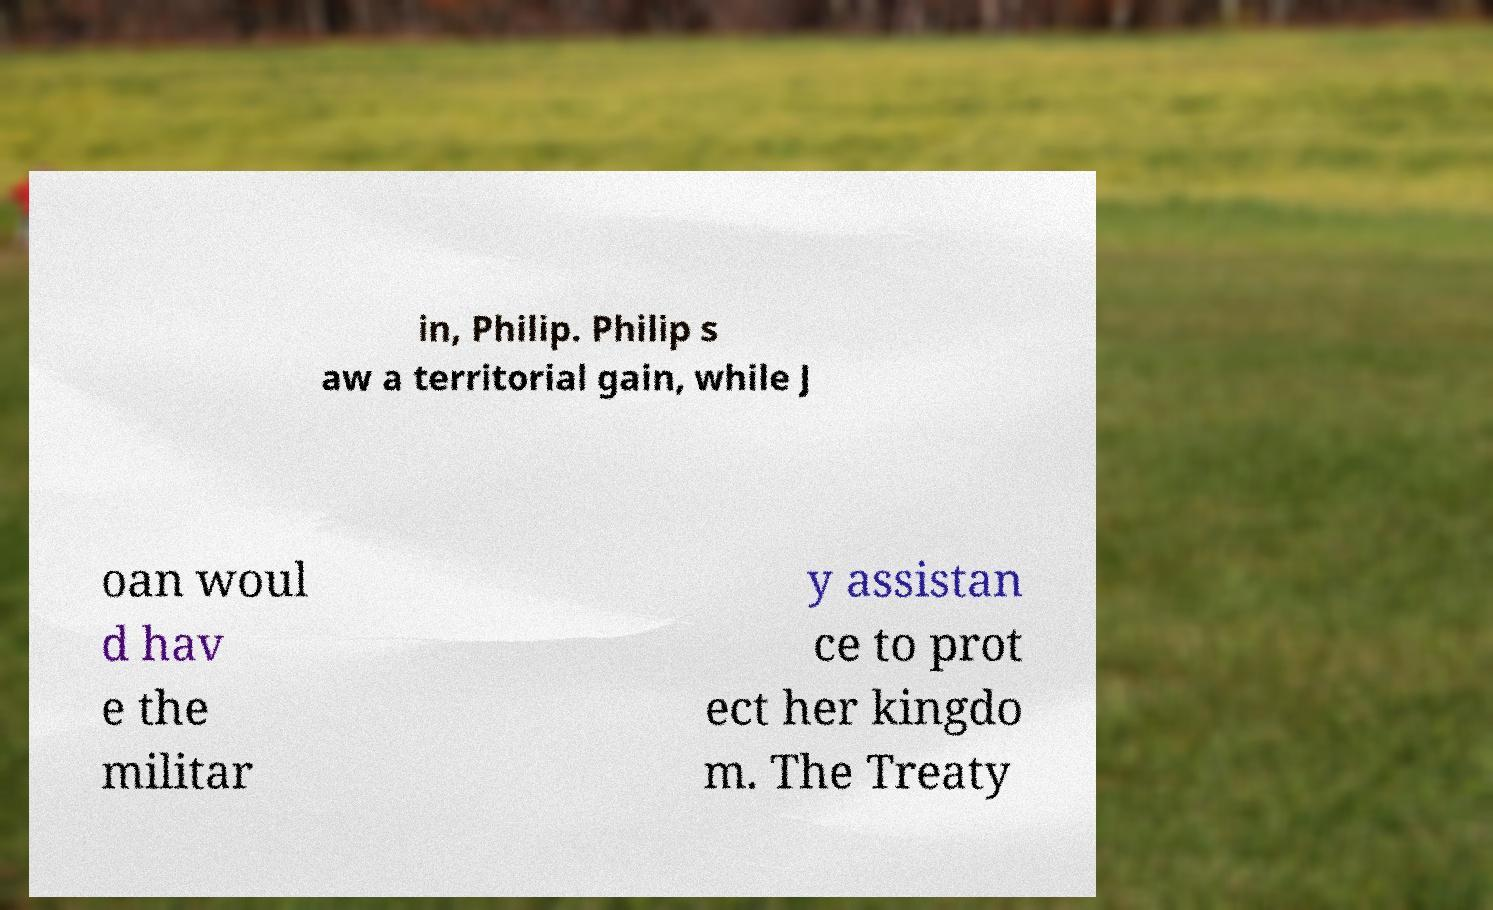What messages or text are displayed in this image? I need them in a readable, typed format. in, Philip. Philip s aw a territorial gain, while J oan woul d hav e the militar y assistan ce to prot ect her kingdo m. The Treaty 